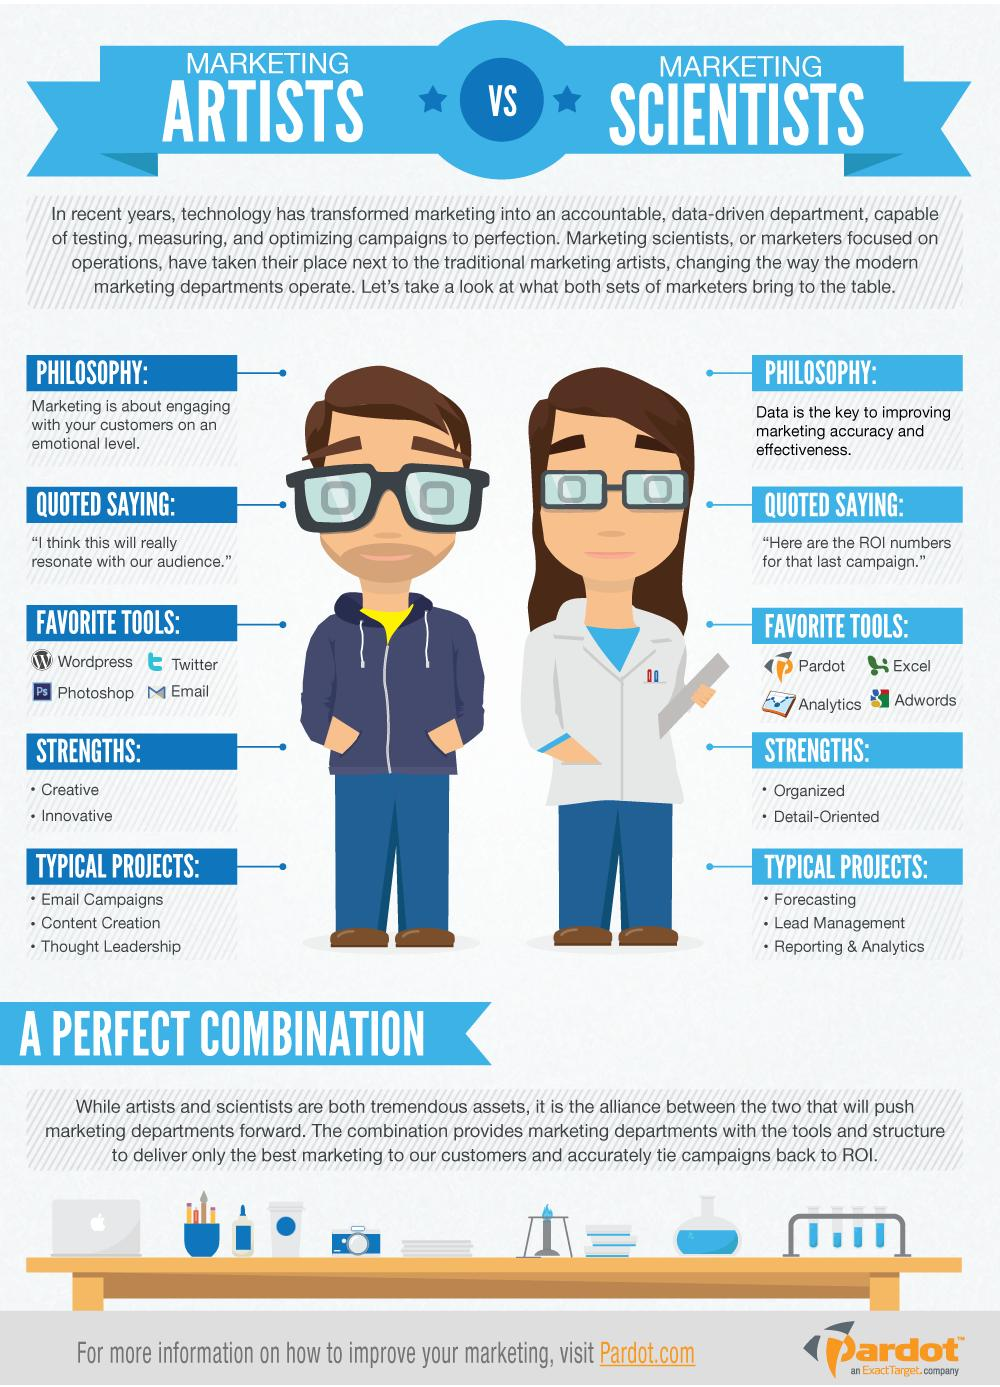Indicate a few pertinent items in this graphic. Marketing Artists possess exceptional strengths in creativity and innovation, making them highly skilled in developing and executing effective marketing strategies. There are four favorite tools for Marketing Scientists. I have identified four favorite tools for marketing artists. Marketing scientists possess strengths such as being organized and detail-oriented. Marketing Artists typically work on projects that involve creating and designing email campaigns, developing content, and showcasing thought leadership. 